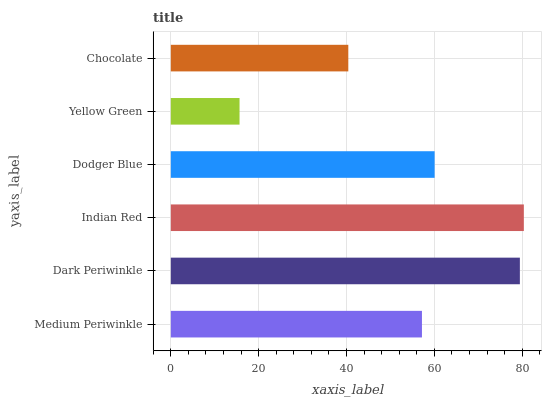Is Yellow Green the minimum?
Answer yes or no. Yes. Is Indian Red the maximum?
Answer yes or no. Yes. Is Dark Periwinkle the minimum?
Answer yes or no. No. Is Dark Periwinkle the maximum?
Answer yes or no. No. Is Dark Periwinkle greater than Medium Periwinkle?
Answer yes or no. Yes. Is Medium Periwinkle less than Dark Periwinkle?
Answer yes or no. Yes. Is Medium Periwinkle greater than Dark Periwinkle?
Answer yes or no. No. Is Dark Periwinkle less than Medium Periwinkle?
Answer yes or no. No. Is Dodger Blue the high median?
Answer yes or no. Yes. Is Medium Periwinkle the low median?
Answer yes or no. Yes. Is Yellow Green the high median?
Answer yes or no. No. Is Chocolate the low median?
Answer yes or no. No. 